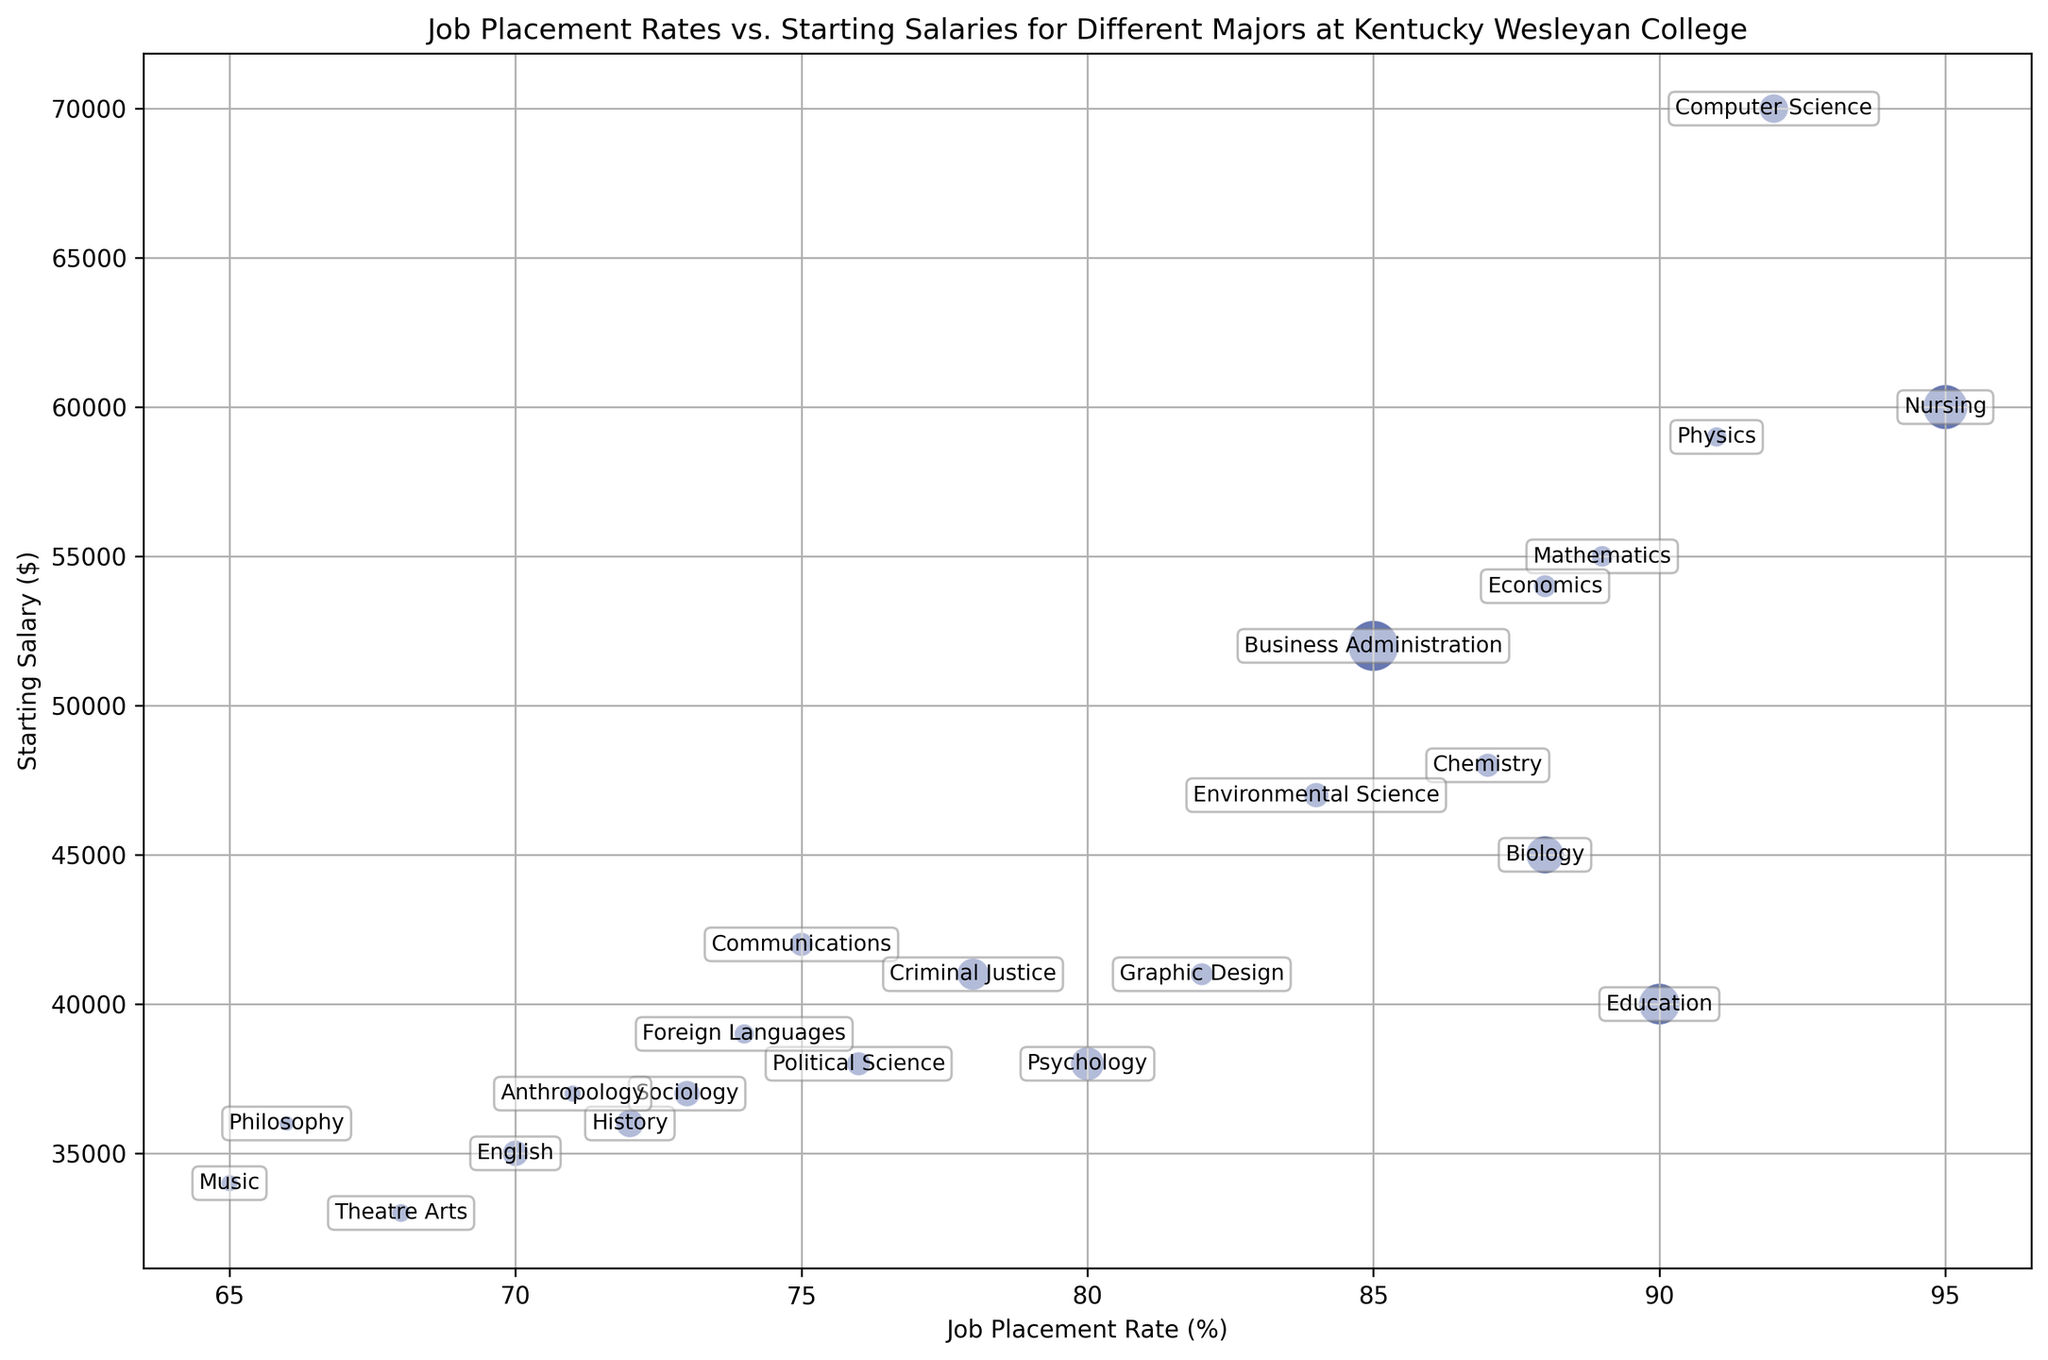What's the major with the highest starting salary? Look at the vertical axis (Starting Salary) and identify the major whose bubble is the highest.
Answer: Computer Science Which major has the highest job placement rate? Identify the major whose bubble is farthest to the right on the horizontal axis (Job Placement Rate).
Answer: Nursing How many majors have a job placement rate greater than 85% and a starting salary above $50,000? Check the region where Job Placement Rate > 85% and Starting Salary > $50,000 to count the bubbles in that area.
Answer: Three (Computer Science, Mathematics, Nursing) Which major has the smallest number of graduates and what is its starting salary? Locate the smallest bubble and read the starting salary value.
Answer: Philosophy, $36,000 What is the total number of graduates from majors with a job placement rate less than 75%? Identify bubbles with Job Placement Rate < 75% and sum their Number of Graduates.
Answer: 5 (Music) + 6 (Theatre Arts) + 12 (English) + 14 (History) + 4 (Philosophy) + 5 (Anthropology) = 46 Which major has a lower job placement rate but equal or higher starting salary than Education? Look for a major with Job Placement Rate < 90% but Starting Salary >= $40,000.
Answer: Biology ($45,000), Business Administration ($52,000), Chemistry ($48,000), Environmental Science ($47,000) Are there more majors with job placement rates greater than or equal to 80% or starting salaries greater than $50,000? Count majors (bubbles) that fit each criterion: Job Placement Rate >= 80% or Starting Salary > $50,000.
Answer: More majors have Job Placement Rate >= 80% What is the average starting salary for the majors with a job placement rate of 90% or more? Identify bubbles with Job Placement Rate >= 90% and calculate the average of their Starting Salaries: (60000+70000+59000) / 3.
Answer: $63,000 Which major has the closest starting salary to History? Find the bubble (major) closest to History vertically (Salary axis).
Answer: Philosophy ($36,000) How much higher is the starting salary of the major with the highest placement rate compared to the one with the lowest rate? Identify Nursing and Music, the highest and lowest placement rate majors respectively, then subtract their starting salaries.
Answer: $60,000 - $34,000 = $26,000 